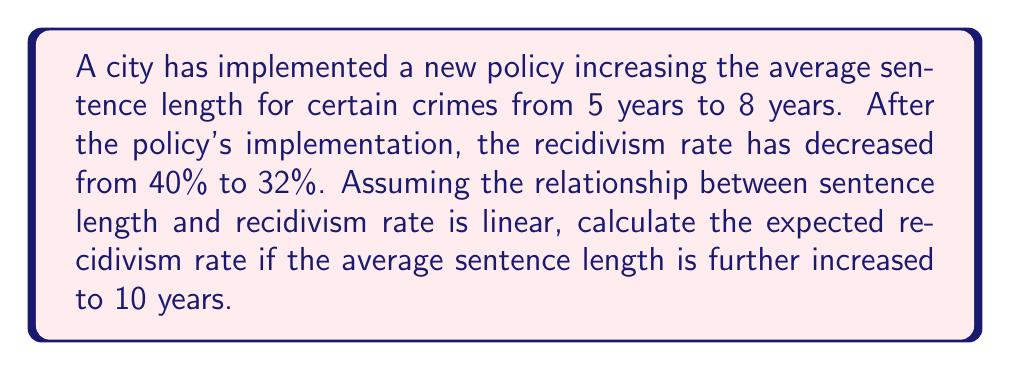Can you answer this question? 1) Let's define our variables:
   $x$ = sentence length in years
   $y$ = recidivism rate as a decimal

2) We have two points to establish our linear relationship:
   $(5, 0.40)$ and $(8, 0.32)$

3) We can use the point-slope form of a line to find our equation:
   $y - y_1 = m(x - x_1)$

4) First, calculate the slope $m$:
   $m = \frac{y_2 - y_1}{x_2 - x_1} = \frac{0.32 - 0.40}{8 - 5} = \frac{-0.08}{3} = -\frac{8}{30}$

5) Now we can use either point to create our equation. Let's use $(5, 0.40)$:
   $y - 0.40 = -\frac{8}{30}(x - 5)$

6) Simplify:
   $y = -\frac{8}{30}x + \frac{40}{30} + 0.40$
   $y = -\frac{8}{30}x + \frac{52}{30}$

7) To find the recidivism rate for a 10-year sentence, substitute $x = 10$:
   $y = -\frac{8}{30}(10) + \frac{52}{30}$
   $y = -\frac{80}{30} + \frac{52}{30}$
   $y = -\frac{28}{30} = -\frac{14}{15} \approx 0.2667$

8) Convert to a percentage:
   $0.2667 \times 100\% = 26.67\%$
Answer: 26.67% 